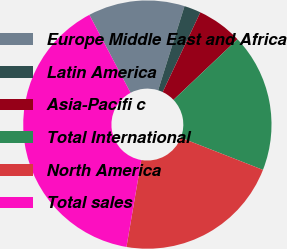<chart> <loc_0><loc_0><loc_500><loc_500><pie_chart><fcel>Europe Middle East and Africa<fcel>Latin America<fcel>Asia-Pacifi c<fcel>Total International<fcel>North America<fcel>Total sales<nl><fcel>12.58%<fcel>2.18%<fcel>5.92%<fcel>18.01%<fcel>21.75%<fcel>39.57%<nl></chart> 